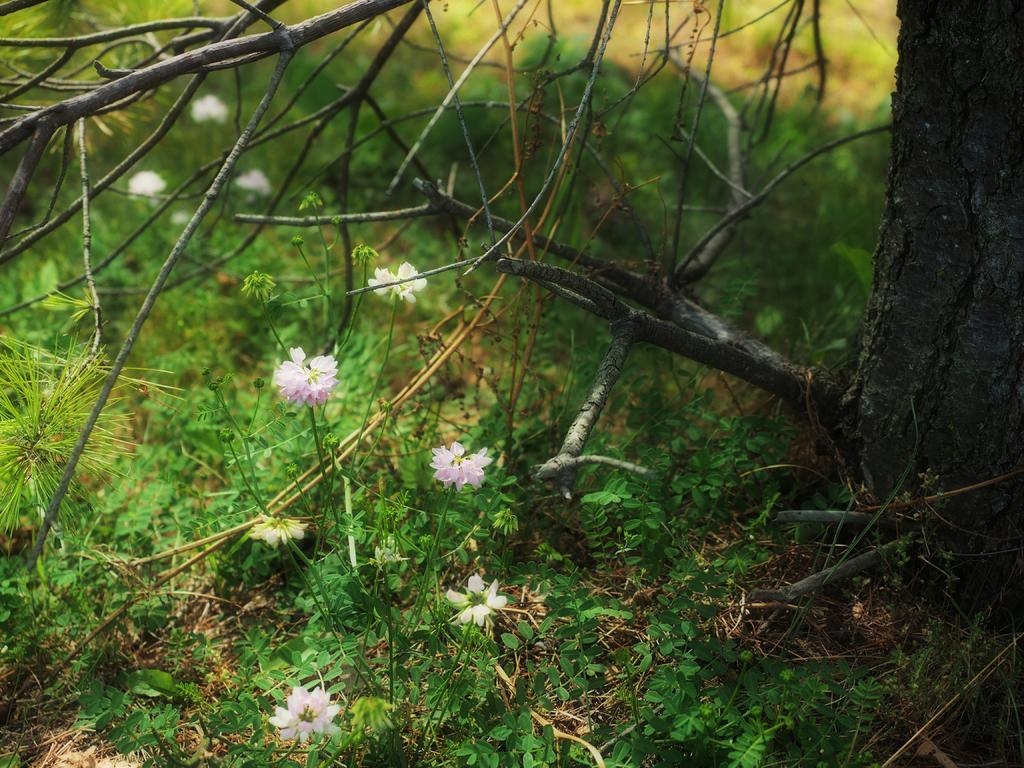What is the main feature of the image? There is a tree trunk in the image. What else can be seen around the tree trunk? There are dry branches in the image. What type of vegetation is present in the image? There is grass in the image. Are there any other plants visible besides the grass? Yes, small flowers are present among the grass. How much glue is needed to attach the approval to the parcel in the image? There is no glue, approval, or parcel present in the image. 